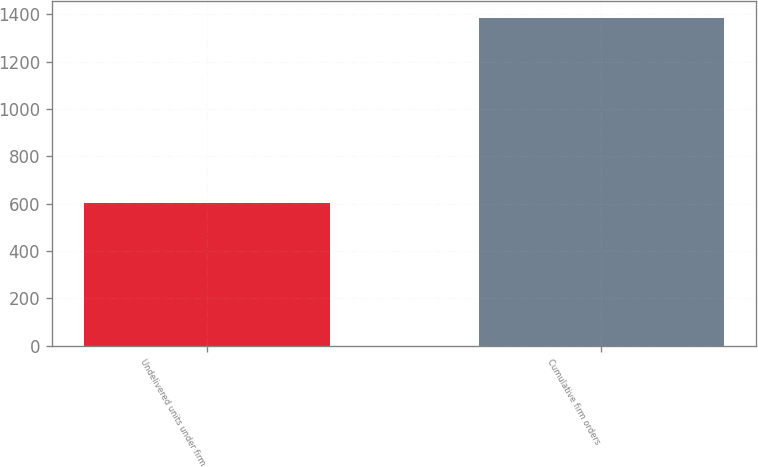<chart> <loc_0><loc_0><loc_500><loc_500><bar_chart><fcel>Undelivered units under firm<fcel>Cumulative firm orders<nl><fcel>604<fcel>1385<nl></chart> 